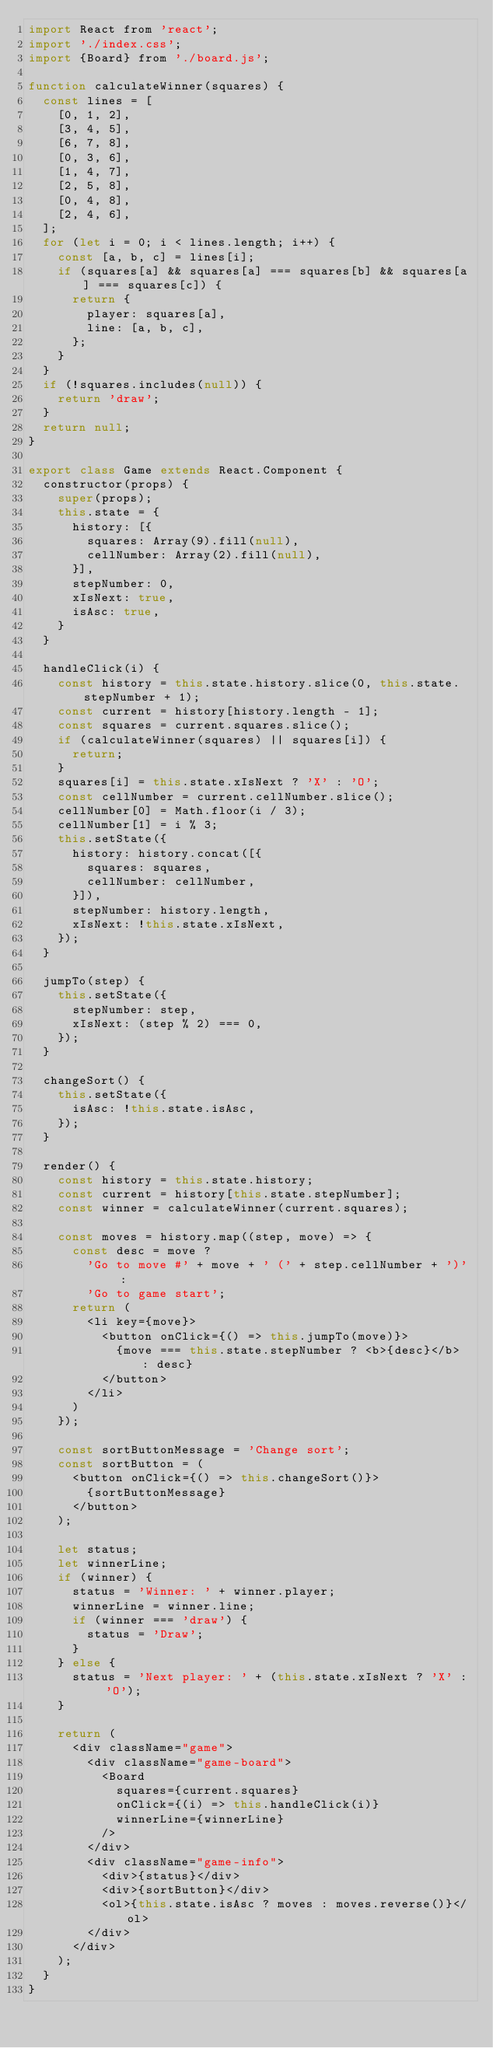Convert code to text. <code><loc_0><loc_0><loc_500><loc_500><_JavaScript_>import React from 'react';
import './index.css';
import {Board} from './board.js';

function calculateWinner(squares) {
  const lines = [
    [0, 1, 2],
    [3, 4, 5],
    [6, 7, 8],
    [0, 3, 6],
    [1, 4, 7],
    [2, 5, 8],
    [0, 4, 8],
    [2, 4, 6],
  ];
  for (let i = 0; i < lines.length; i++) {
    const [a, b, c] = lines[i];
    if (squares[a] && squares[a] === squares[b] && squares[a] === squares[c]) {
      return {
        player: squares[a],
        line: [a, b, c],
      };
    }
  }
  if (!squares.includes(null)) {
    return 'draw';
  }
  return null;
}

export class Game extends React.Component {
  constructor(props) {
    super(props);
    this.state = {
      history: [{
        squares: Array(9).fill(null),
        cellNumber: Array(2).fill(null),
      }],
      stepNumber: 0,
      xIsNext: true,
      isAsc: true,
    }
  }

  handleClick(i) {
    const history = this.state.history.slice(0, this.state.stepNumber + 1);
    const current = history[history.length - 1];
    const squares = current.squares.slice();
    if (calculateWinner(squares) || squares[i]) {
      return;
    }
    squares[i] = this.state.xIsNext ? 'X' : 'O';
    const cellNumber = current.cellNumber.slice();
    cellNumber[0] = Math.floor(i / 3);
    cellNumber[1] = i % 3;
    this.setState({
      history: history.concat([{
        squares: squares,
        cellNumber: cellNumber,
      }]),
      stepNumber: history.length,
      xIsNext: !this.state.xIsNext,
    });
  }

  jumpTo(step) {
    this.setState({
      stepNumber: step,
      xIsNext: (step % 2) === 0,
    });
  }

  changeSort() {
    this.setState({
      isAsc: !this.state.isAsc,
    });
  }

  render() {
    const history = this.state.history;
    const current = history[this.state.stepNumber];
    const winner = calculateWinner(current.squares);

    const moves = history.map((step, move) => {
      const desc = move ?
        'Go to move #' + move + ' (' + step.cellNumber + ')' : 
        'Go to game start';
      return (
        <li key={move}>
          <button onClick={() => this.jumpTo(move)}>
            {move === this.state.stepNumber ? <b>{desc}</b> : desc}
          </button>
        </li>
      )
    });

    const sortButtonMessage = 'Change sort';
    const sortButton = (
      <button onClick={() => this.changeSort()}>
        {sortButtonMessage}
      </button>
    );

    let status;
    let winnerLine;
    if (winner) { 
      status = 'Winner: ' + winner.player;
      winnerLine = winner.line;
      if (winner === 'draw') {
        status = 'Draw';
      }
    } else { 
      status = 'Next player: ' + (this.state.xIsNext ? 'X' : 'O');
    }

    return (
      <div className="game">
        <div className="game-board">
          <Board
            squares={current.squares}
            onClick={(i) => this.handleClick(i)}
            winnerLine={winnerLine}
          />
        </div>
        <div className="game-info">
          <div>{status}</div>
          <div>{sortButton}</div>
          <ol>{this.state.isAsc ? moves : moves.reverse()}</ol>
        </div>
      </div>
    );
  }
}
</code> 